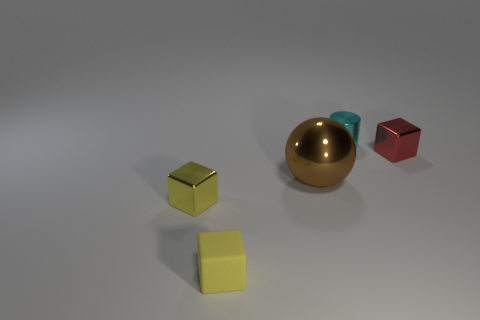Subtract all red blocks. How many blocks are left? 2 Subtract all small yellow cubes. How many cubes are left? 1 Subtract 0 purple blocks. How many objects are left? 5 Subtract all cylinders. How many objects are left? 4 Subtract 1 balls. How many balls are left? 0 Subtract all purple cubes. Subtract all green spheres. How many cubes are left? 3 Subtract all brown spheres. How many yellow cubes are left? 2 Subtract all red objects. Subtract all big cylinders. How many objects are left? 4 Add 1 yellow rubber things. How many yellow rubber things are left? 2 Add 5 gray matte cylinders. How many gray matte cylinders exist? 5 